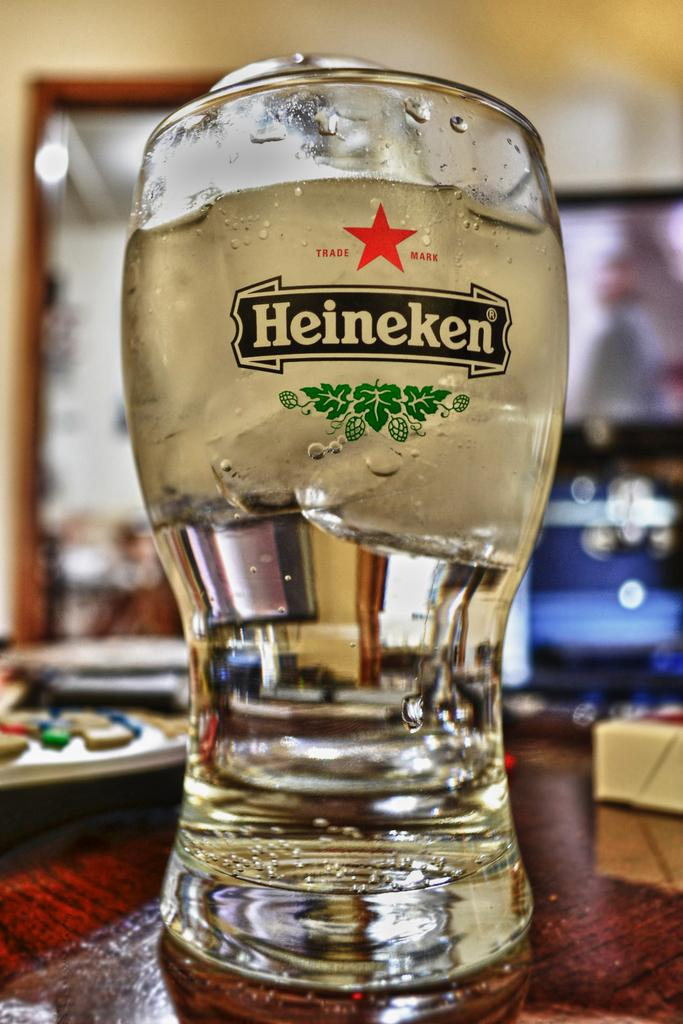<image>
Give a short and clear explanation of the subsequent image. A mostly full glass of Trade Mark Heineken with ice floating on top. 